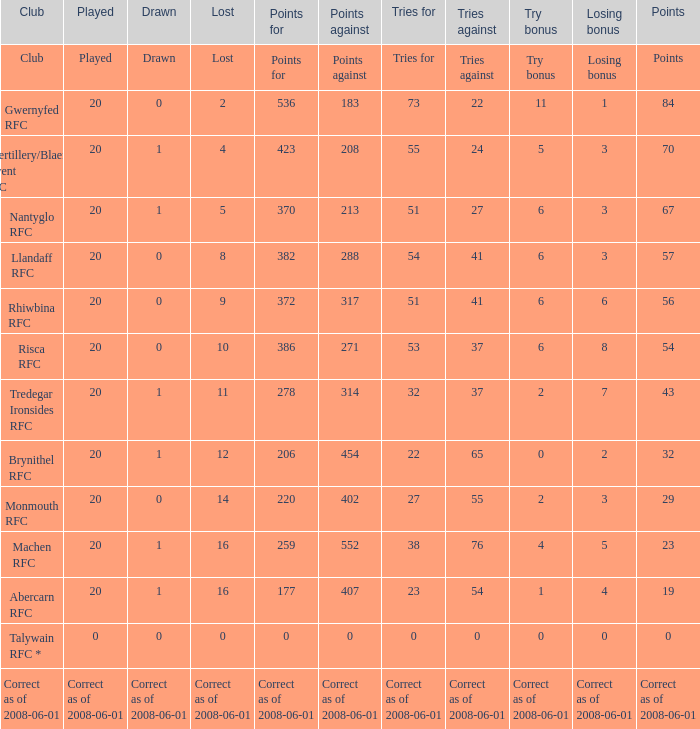If the score was 0, what was the losing reward? 0.0. 